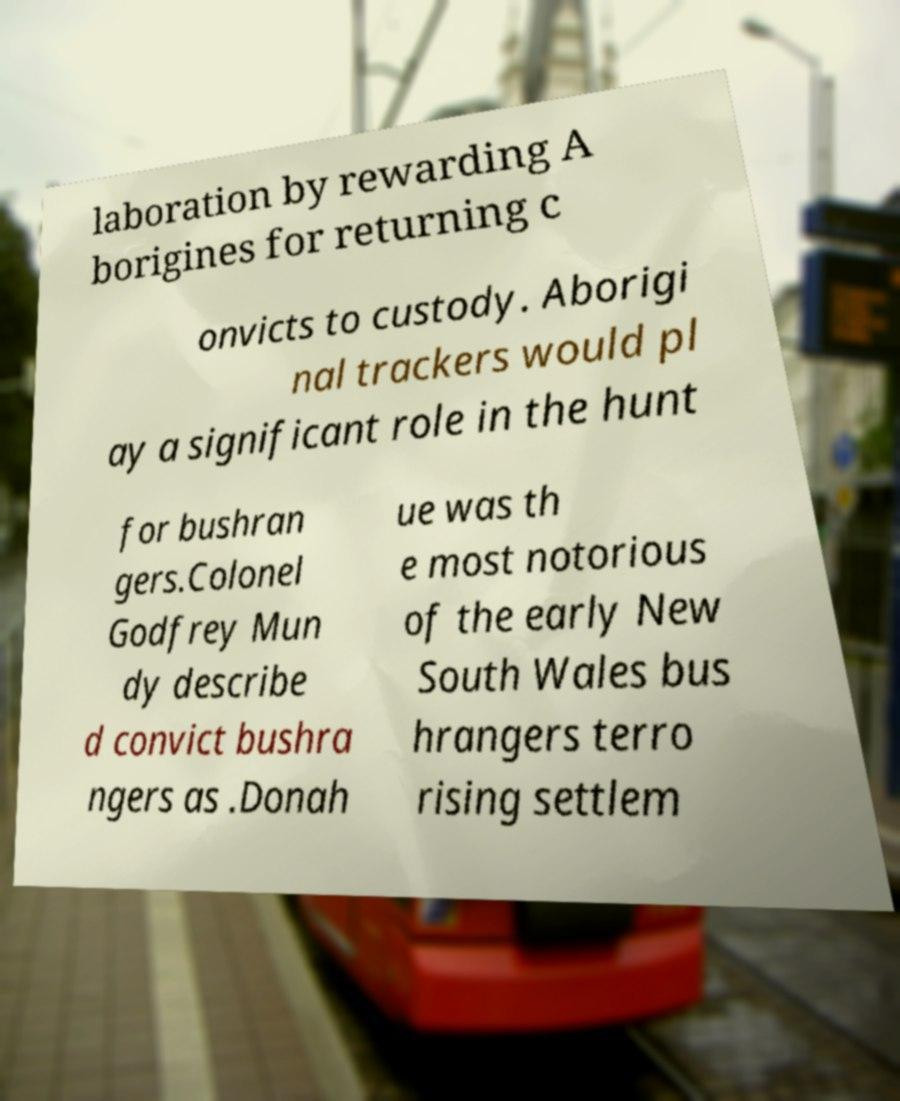Please identify and transcribe the text found in this image. laboration by rewarding A borigines for returning c onvicts to custody. Aborigi nal trackers would pl ay a significant role in the hunt for bushran gers.Colonel Godfrey Mun dy describe d convict bushra ngers as .Donah ue was th e most notorious of the early New South Wales bus hrangers terro rising settlem 